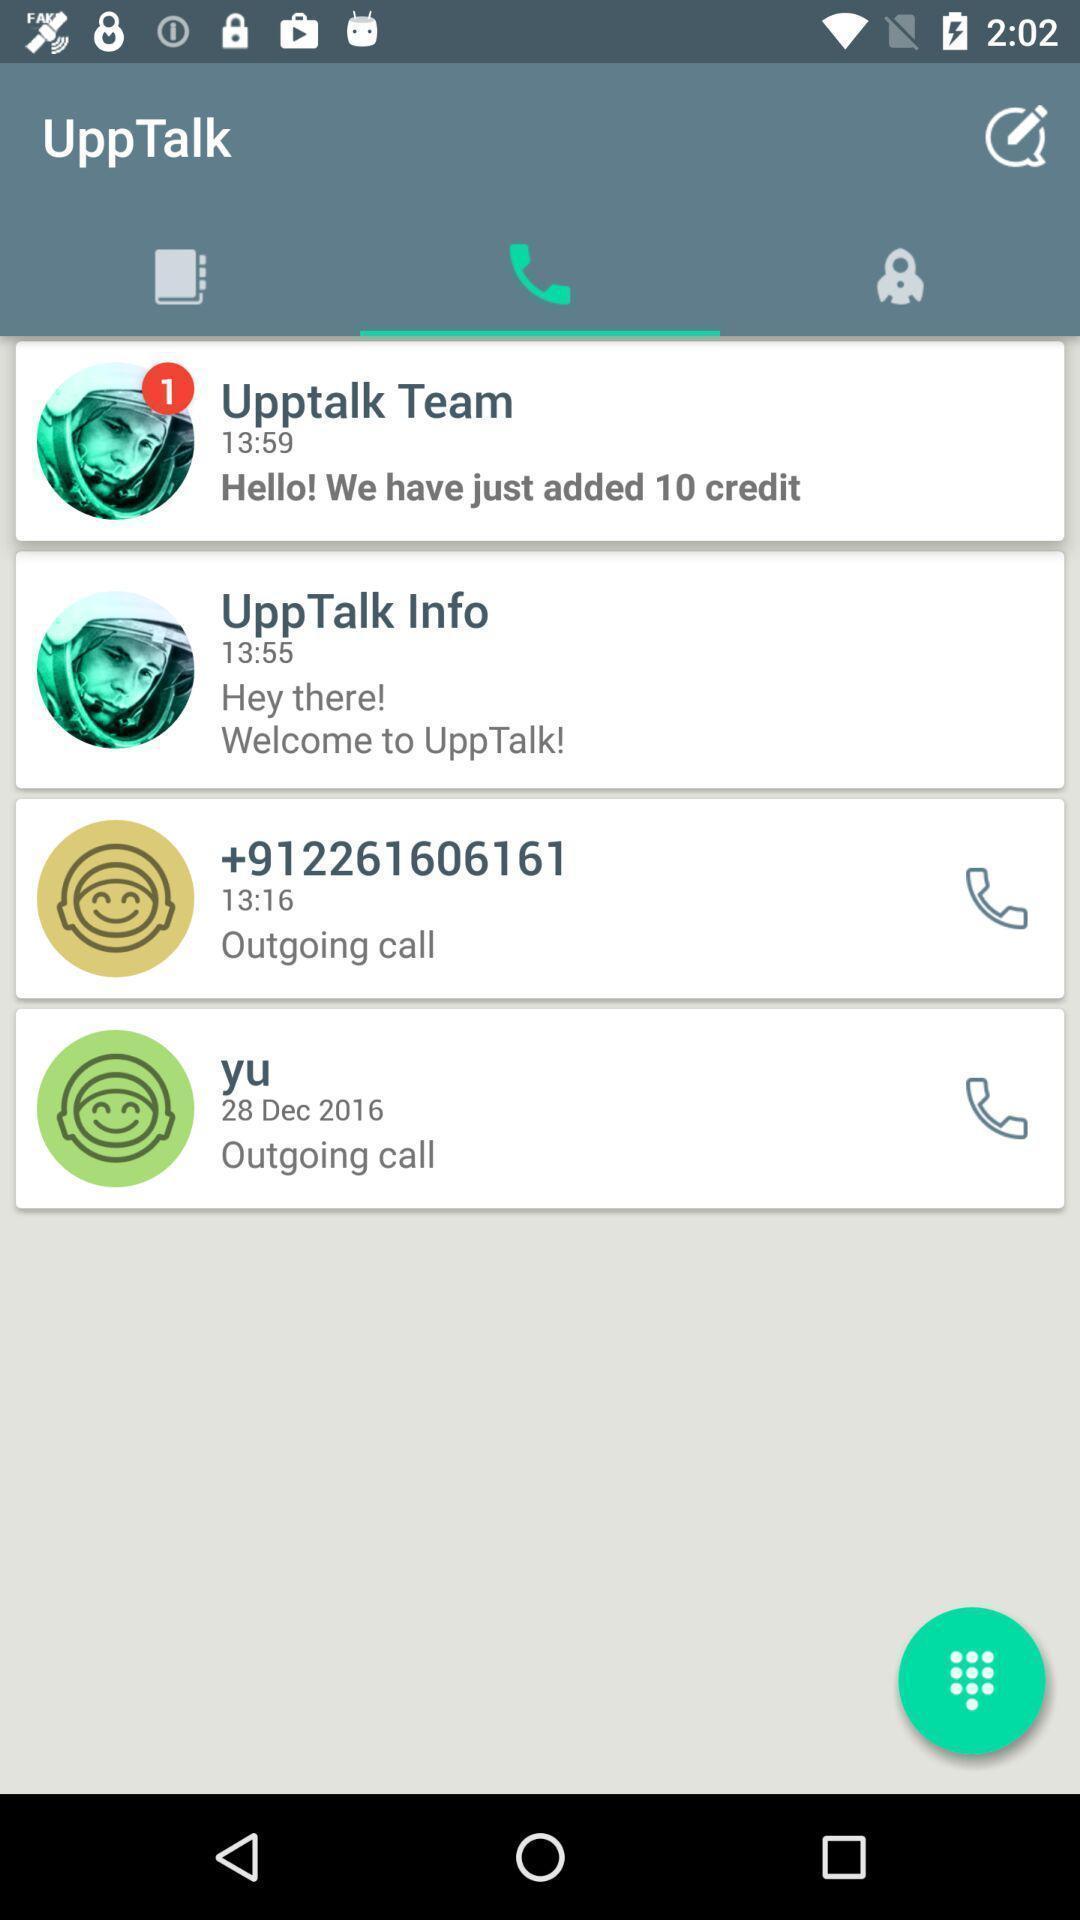Describe the visual elements of this screenshot. Screen shows list of calls. 